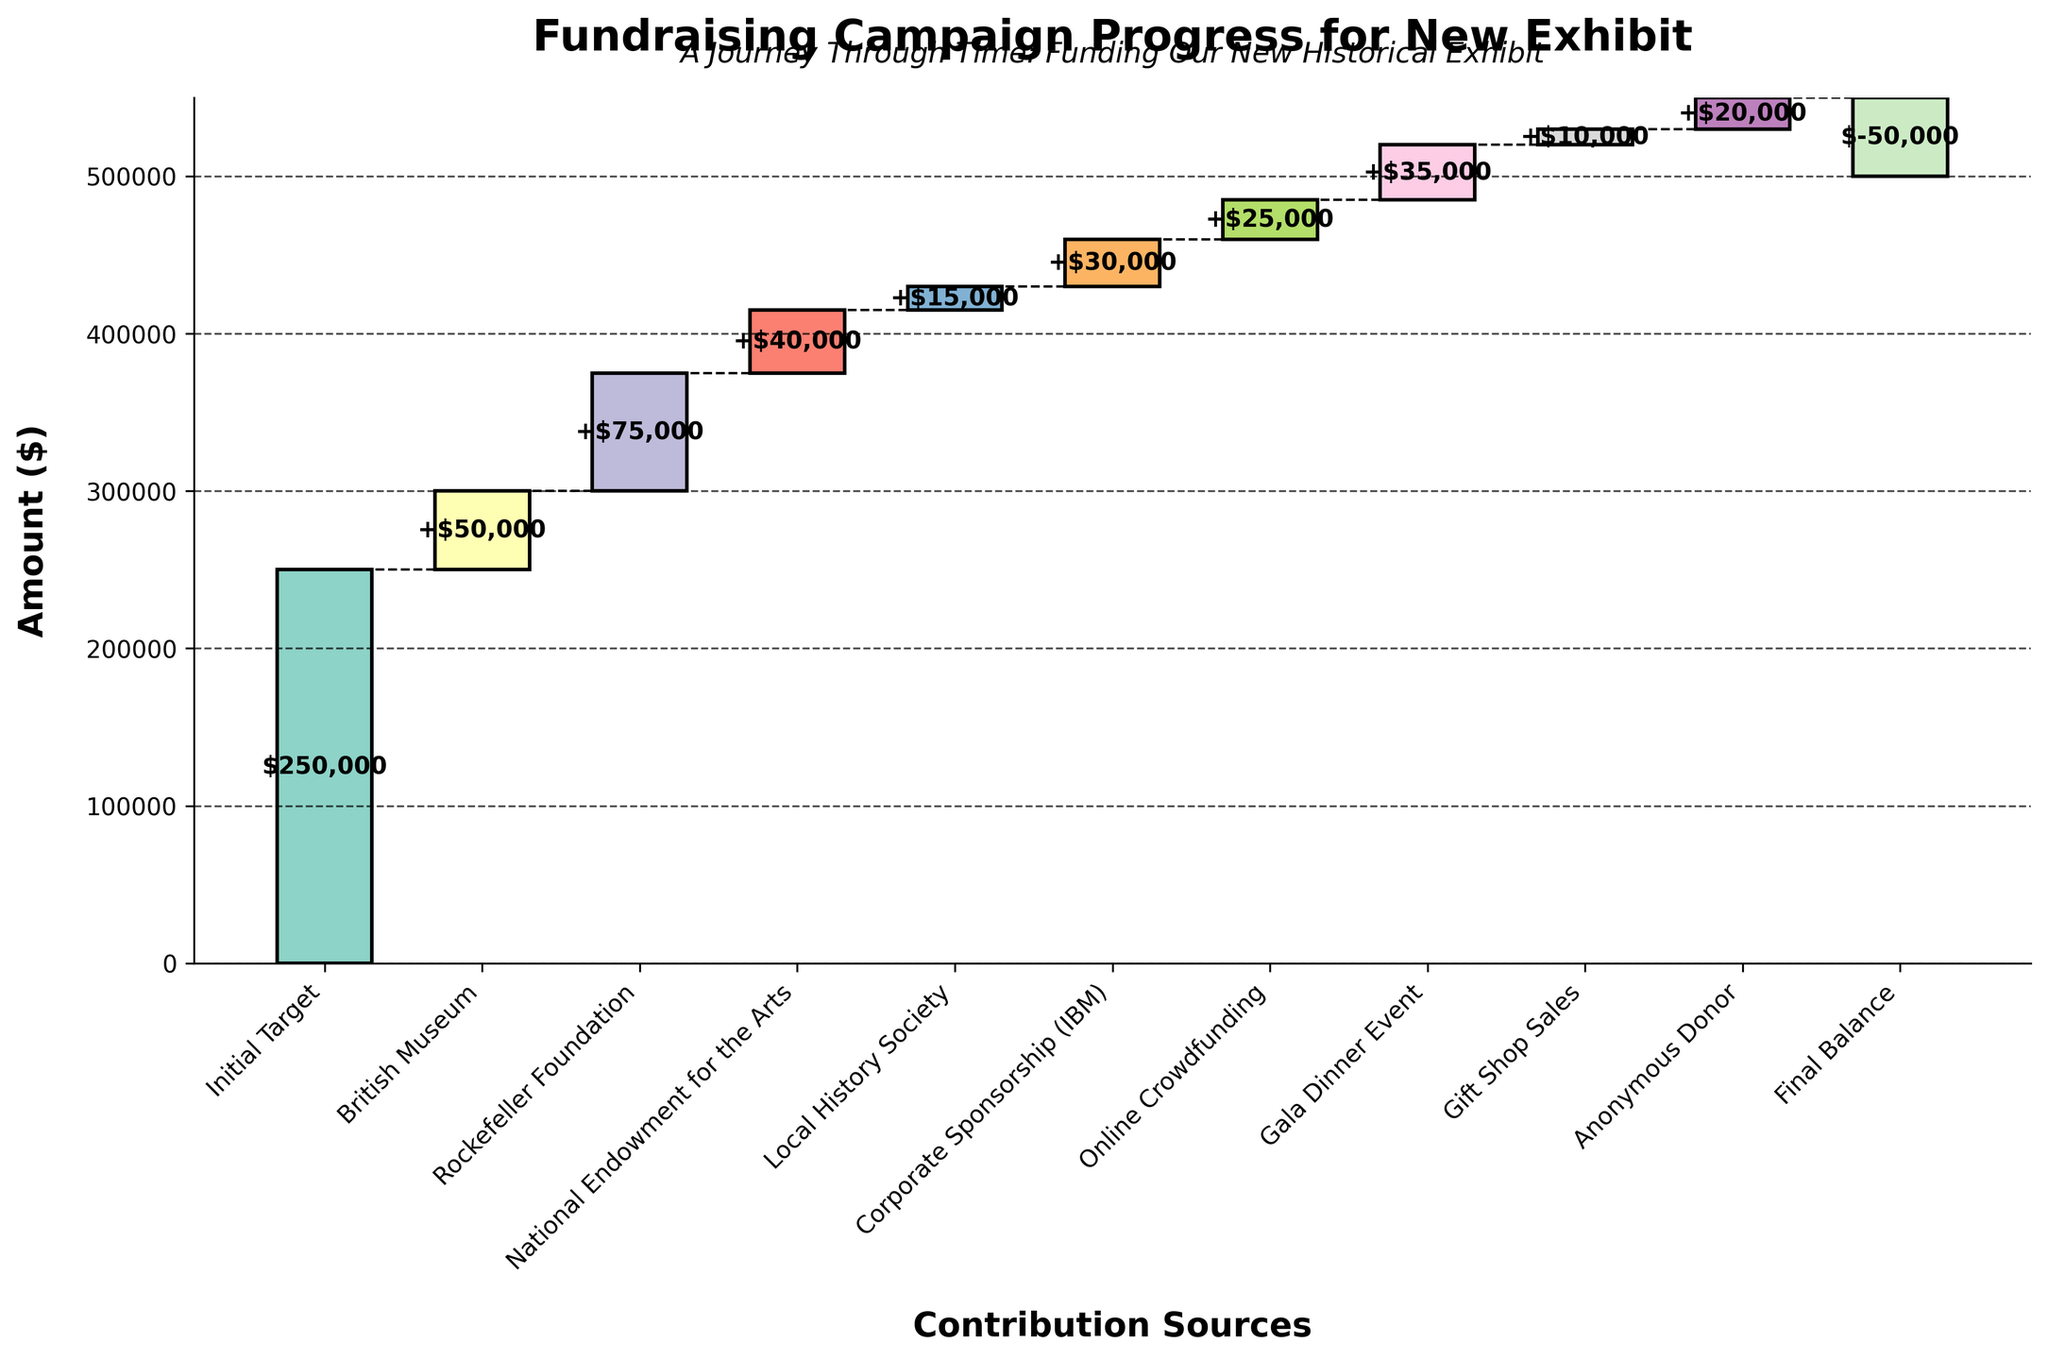What is the title of the figure? The title of the figure is displayed at the top center of the image. It reads "Fundraising Campaign Progress for New Exhibit".
Answer: Fundraising Campaign Progress for New Exhibit Which donor contributed the highest amount? When looking at each segment of the bar, the segment with the highest value is the one labeled "Rockefeller Foundation" with $75,000, which may also be recognized due to its significant height.
Answer: Rockefeller Foundation How much total funding was acquired from corporate or organizational sources, excluding individual donors? Sum the amounts contributed by British Museum, Rockefeller Foundation, National Endowment for the Arts, Local History Society, and Corporate Sponsorship (IBM). That's 50,000 + 75,000 + 40,000 + 15,000 + 30,000.
Answer: $210,000 What is the final balance after all contributions? Look for the final segment labeled "Final Balance" which shows -$50,000, indicating the remaining shortfall in the fundraising campaign.
Answer: -$50,000 How does the initial target compare to the sum of all contributions? The initial target is $250,000. Sum all contributions: 50,000 + 75,000 + 40,000 + 15,000 + 30,000 + 25,000 + 35,000 + 10,000 + 20,000 which equals $300,000. Compare this total to the initial target.
Answer: $50,000 over the target Which two contributions are closest in value? Comparing each pair of contributions in the figure, the "Gala Dinner Event" and "Corporate Sponsorship (IBM)" are closest, with $35,000 and $30,000 respectively, a difference of $5,000.
Answer: Gala Dinner Event and Corporate Sponsorship (IBM) What is the cumulative total after the first five contributions? Cumulatively add the first five contributions starting after the initial target: 50,000 + 75,000 + 40,000 + 15,000 + 30,000. The initial target is $250,000 so 250,000 + 210,000 = $460,000.
Answer: $460,000 Which contribution brought the total over the initial target? Add cumulative contributions in sequence: starting from 0, after British Museum 50,000, then Rockefeller Foundation 125,000, National Endowment for the Arts 165,000, Local History Society 180,000, and Corporate Sponsorship (IBM) 210,000. The initial target is 250,000 and after the Corporate Sponsorship the next contribution which is Online Crowdfunding brings the total to 235,000 + 25,000 = $260,000 surpassing the target.
Answer: Online Crowdfunding What is the difference between the highest and lowest individual contributions? The highest contribution came from the "Rockefeller Foundation" at $75,000 and the lowest from "Gift Shop Sales" at $10,000. Subtract the lowest from the highest 75,000 - 10,000 = 65,000.
Answer: $65,000 